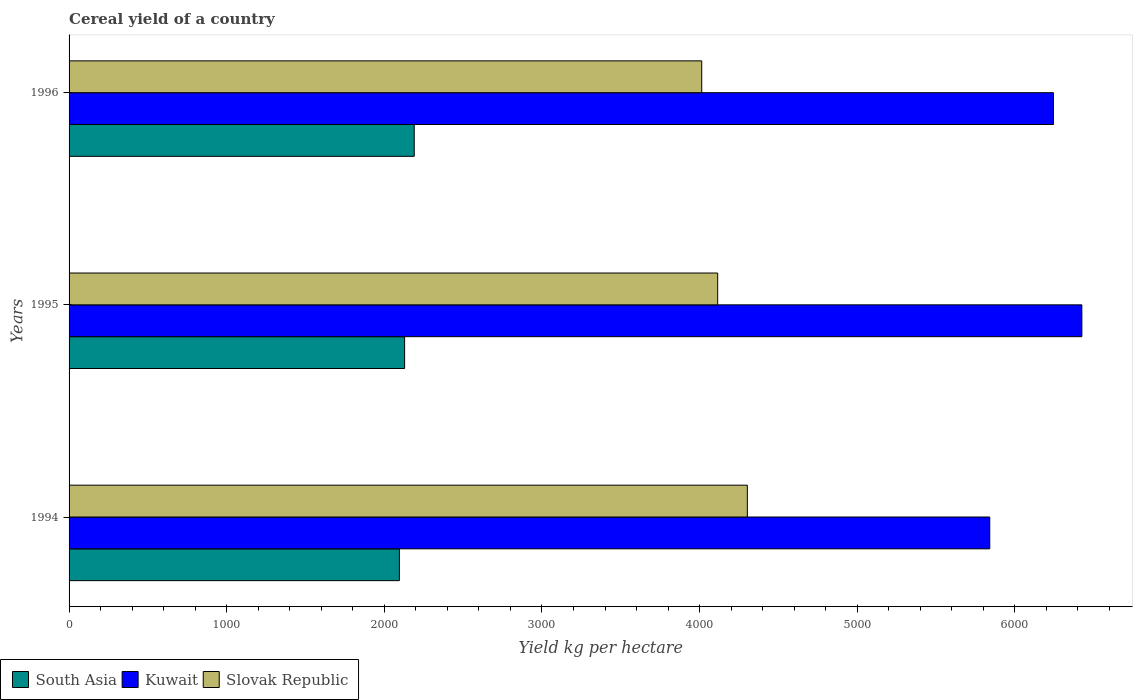How many different coloured bars are there?
Offer a terse response. 3. How many groups of bars are there?
Your answer should be very brief. 3. Are the number of bars on each tick of the Y-axis equal?
Make the answer very short. Yes. In how many cases, is the number of bars for a given year not equal to the number of legend labels?
Make the answer very short. 0. What is the total cereal yield in Slovak Republic in 1995?
Your answer should be very brief. 4114.81. Across all years, what is the maximum total cereal yield in South Asia?
Your answer should be very brief. 2189.71. Across all years, what is the minimum total cereal yield in Slovak Republic?
Your answer should be compact. 4013.58. In which year was the total cereal yield in Kuwait maximum?
Your answer should be compact. 1995. What is the total total cereal yield in Slovak Republic in the graph?
Keep it short and to the point. 1.24e+04. What is the difference between the total cereal yield in Kuwait in 1994 and that in 1995?
Keep it short and to the point. -584.17. What is the difference between the total cereal yield in South Asia in 1994 and the total cereal yield in Kuwait in 1995?
Give a very brief answer. -4329.56. What is the average total cereal yield in South Asia per year?
Offer a terse response. 2137.96. In the year 1996, what is the difference between the total cereal yield in Slovak Republic and total cereal yield in South Asia?
Keep it short and to the point. 1823.87. In how many years, is the total cereal yield in South Asia greater than 5400 kg per hectare?
Offer a very short reply. 0. What is the ratio of the total cereal yield in South Asia in 1995 to that in 1996?
Offer a very short reply. 0.97. Is the total cereal yield in Kuwait in 1994 less than that in 1995?
Keep it short and to the point. Yes. What is the difference between the highest and the second highest total cereal yield in Kuwait?
Your response must be concise. 180.1. What is the difference between the highest and the lowest total cereal yield in Kuwait?
Your answer should be very brief. 584.17. Is the sum of the total cereal yield in Kuwait in 1994 and 1995 greater than the maximum total cereal yield in Slovak Republic across all years?
Your answer should be very brief. Yes. What does the 1st bar from the top in 1996 represents?
Offer a very short reply. Slovak Republic. How many bars are there?
Provide a succinct answer. 9. Are all the bars in the graph horizontal?
Provide a succinct answer. Yes. What is the difference between two consecutive major ticks on the X-axis?
Offer a terse response. 1000. Are the values on the major ticks of X-axis written in scientific E-notation?
Provide a succinct answer. No. Does the graph contain any zero values?
Make the answer very short. No. Does the graph contain grids?
Offer a very short reply. No. How many legend labels are there?
Offer a terse response. 3. How are the legend labels stacked?
Your answer should be very brief. Horizontal. What is the title of the graph?
Offer a terse response. Cereal yield of a country. Does "Moldova" appear as one of the legend labels in the graph?
Your response must be concise. No. What is the label or title of the X-axis?
Your answer should be compact. Yield kg per hectare. What is the Yield kg per hectare in South Asia in 1994?
Your answer should be very brief. 2095.52. What is the Yield kg per hectare of Kuwait in 1994?
Offer a very short reply. 5840.91. What is the Yield kg per hectare of Slovak Republic in 1994?
Offer a terse response. 4302.99. What is the Yield kg per hectare of South Asia in 1995?
Your answer should be very brief. 2128.66. What is the Yield kg per hectare of Kuwait in 1995?
Offer a terse response. 6425.08. What is the Yield kg per hectare in Slovak Republic in 1995?
Give a very brief answer. 4114.81. What is the Yield kg per hectare in South Asia in 1996?
Keep it short and to the point. 2189.71. What is the Yield kg per hectare of Kuwait in 1996?
Offer a terse response. 6244.97. What is the Yield kg per hectare in Slovak Republic in 1996?
Offer a very short reply. 4013.58. Across all years, what is the maximum Yield kg per hectare of South Asia?
Offer a very short reply. 2189.71. Across all years, what is the maximum Yield kg per hectare in Kuwait?
Your answer should be compact. 6425.08. Across all years, what is the maximum Yield kg per hectare of Slovak Republic?
Your answer should be compact. 4302.99. Across all years, what is the minimum Yield kg per hectare in South Asia?
Your response must be concise. 2095.52. Across all years, what is the minimum Yield kg per hectare of Kuwait?
Offer a terse response. 5840.91. Across all years, what is the minimum Yield kg per hectare in Slovak Republic?
Keep it short and to the point. 4013.58. What is the total Yield kg per hectare in South Asia in the graph?
Offer a terse response. 6413.89. What is the total Yield kg per hectare of Kuwait in the graph?
Keep it short and to the point. 1.85e+04. What is the total Yield kg per hectare of Slovak Republic in the graph?
Ensure brevity in your answer.  1.24e+04. What is the difference between the Yield kg per hectare in South Asia in 1994 and that in 1995?
Provide a succinct answer. -33.15. What is the difference between the Yield kg per hectare of Kuwait in 1994 and that in 1995?
Provide a succinct answer. -584.17. What is the difference between the Yield kg per hectare of Slovak Republic in 1994 and that in 1995?
Your answer should be compact. 188.18. What is the difference between the Yield kg per hectare of South Asia in 1994 and that in 1996?
Keep it short and to the point. -94.19. What is the difference between the Yield kg per hectare of Kuwait in 1994 and that in 1996?
Your response must be concise. -404.06. What is the difference between the Yield kg per hectare in Slovak Republic in 1994 and that in 1996?
Provide a succinct answer. 289.41. What is the difference between the Yield kg per hectare of South Asia in 1995 and that in 1996?
Ensure brevity in your answer.  -61.05. What is the difference between the Yield kg per hectare of Kuwait in 1995 and that in 1996?
Your answer should be compact. 180.1. What is the difference between the Yield kg per hectare in Slovak Republic in 1995 and that in 1996?
Provide a short and direct response. 101.23. What is the difference between the Yield kg per hectare in South Asia in 1994 and the Yield kg per hectare in Kuwait in 1995?
Your answer should be very brief. -4329.56. What is the difference between the Yield kg per hectare of South Asia in 1994 and the Yield kg per hectare of Slovak Republic in 1995?
Your answer should be very brief. -2019.29. What is the difference between the Yield kg per hectare of Kuwait in 1994 and the Yield kg per hectare of Slovak Republic in 1995?
Offer a terse response. 1726.1. What is the difference between the Yield kg per hectare in South Asia in 1994 and the Yield kg per hectare in Kuwait in 1996?
Offer a very short reply. -4149.46. What is the difference between the Yield kg per hectare of South Asia in 1994 and the Yield kg per hectare of Slovak Republic in 1996?
Your answer should be very brief. -1918.06. What is the difference between the Yield kg per hectare in Kuwait in 1994 and the Yield kg per hectare in Slovak Republic in 1996?
Your answer should be very brief. 1827.33. What is the difference between the Yield kg per hectare in South Asia in 1995 and the Yield kg per hectare in Kuwait in 1996?
Give a very brief answer. -4116.31. What is the difference between the Yield kg per hectare in South Asia in 1995 and the Yield kg per hectare in Slovak Republic in 1996?
Offer a terse response. -1884.91. What is the difference between the Yield kg per hectare of Kuwait in 1995 and the Yield kg per hectare of Slovak Republic in 1996?
Provide a succinct answer. 2411.5. What is the average Yield kg per hectare of South Asia per year?
Your answer should be compact. 2137.96. What is the average Yield kg per hectare in Kuwait per year?
Give a very brief answer. 6170.32. What is the average Yield kg per hectare of Slovak Republic per year?
Your answer should be compact. 4143.79. In the year 1994, what is the difference between the Yield kg per hectare of South Asia and Yield kg per hectare of Kuwait?
Provide a short and direct response. -3745.39. In the year 1994, what is the difference between the Yield kg per hectare in South Asia and Yield kg per hectare in Slovak Republic?
Your answer should be compact. -2207.47. In the year 1994, what is the difference between the Yield kg per hectare in Kuwait and Yield kg per hectare in Slovak Republic?
Offer a very short reply. 1537.92. In the year 1995, what is the difference between the Yield kg per hectare of South Asia and Yield kg per hectare of Kuwait?
Your answer should be very brief. -4296.41. In the year 1995, what is the difference between the Yield kg per hectare of South Asia and Yield kg per hectare of Slovak Republic?
Offer a very short reply. -1986.14. In the year 1995, what is the difference between the Yield kg per hectare in Kuwait and Yield kg per hectare in Slovak Republic?
Your answer should be compact. 2310.27. In the year 1996, what is the difference between the Yield kg per hectare of South Asia and Yield kg per hectare of Kuwait?
Give a very brief answer. -4055.26. In the year 1996, what is the difference between the Yield kg per hectare in South Asia and Yield kg per hectare in Slovak Republic?
Your answer should be very brief. -1823.87. In the year 1996, what is the difference between the Yield kg per hectare of Kuwait and Yield kg per hectare of Slovak Republic?
Give a very brief answer. 2231.4. What is the ratio of the Yield kg per hectare in South Asia in 1994 to that in 1995?
Offer a terse response. 0.98. What is the ratio of the Yield kg per hectare of Slovak Republic in 1994 to that in 1995?
Give a very brief answer. 1.05. What is the ratio of the Yield kg per hectare in Kuwait in 1994 to that in 1996?
Keep it short and to the point. 0.94. What is the ratio of the Yield kg per hectare in Slovak Republic in 1994 to that in 1996?
Your answer should be very brief. 1.07. What is the ratio of the Yield kg per hectare in South Asia in 1995 to that in 1996?
Provide a short and direct response. 0.97. What is the ratio of the Yield kg per hectare of Kuwait in 1995 to that in 1996?
Your response must be concise. 1.03. What is the ratio of the Yield kg per hectare of Slovak Republic in 1995 to that in 1996?
Your answer should be compact. 1.03. What is the difference between the highest and the second highest Yield kg per hectare of South Asia?
Keep it short and to the point. 61.05. What is the difference between the highest and the second highest Yield kg per hectare of Kuwait?
Make the answer very short. 180.1. What is the difference between the highest and the second highest Yield kg per hectare of Slovak Republic?
Give a very brief answer. 188.18. What is the difference between the highest and the lowest Yield kg per hectare of South Asia?
Provide a succinct answer. 94.19. What is the difference between the highest and the lowest Yield kg per hectare of Kuwait?
Make the answer very short. 584.17. What is the difference between the highest and the lowest Yield kg per hectare in Slovak Republic?
Give a very brief answer. 289.41. 